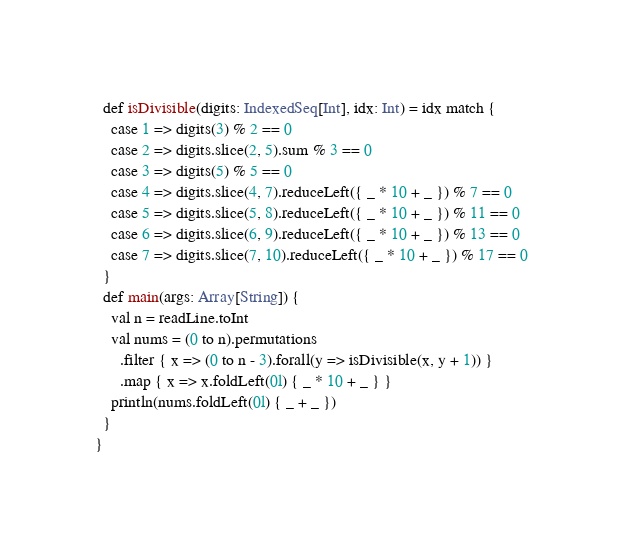<code> <loc_0><loc_0><loc_500><loc_500><_Scala_>  def isDivisible(digits: IndexedSeq[Int], idx: Int) = idx match {
    case 1 => digits(3) % 2 == 0
    case 2 => digits.slice(2, 5).sum % 3 == 0
    case 3 => digits(5) % 5 == 0
    case 4 => digits.slice(4, 7).reduceLeft({ _ * 10 + _ }) % 7 == 0
    case 5 => digits.slice(5, 8).reduceLeft({ _ * 10 + _ }) % 11 == 0
    case 6 => digits.slice(6, 9).reduceLeft({ _ * 10 + _ }) % 13 == 0
    case 7 => digits.slice(7, 10).reduceLeft({ _ * 10 + _ }) % 17 == 0
  }
  def main(args: Array[String]) {
    val n = readLine.toInt
    val nums = (0 to n).permutations
      .filter { x => (0 to n - 3).forall(y => isDivisible(x, y + 1)) }
      .map { x => x.foldLeft(0l) { _ * 10 + _ } }
    println(nums.foldLeft(0l) { _ + _ })
  }
}
</code> 